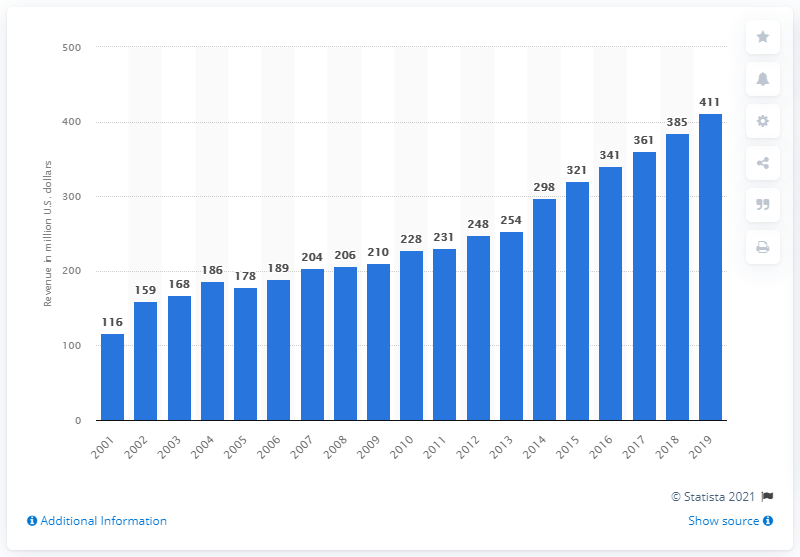Draw attention to some important aspects in this diagram. The revenue of the Detroit Lions in 2019 was 411. 